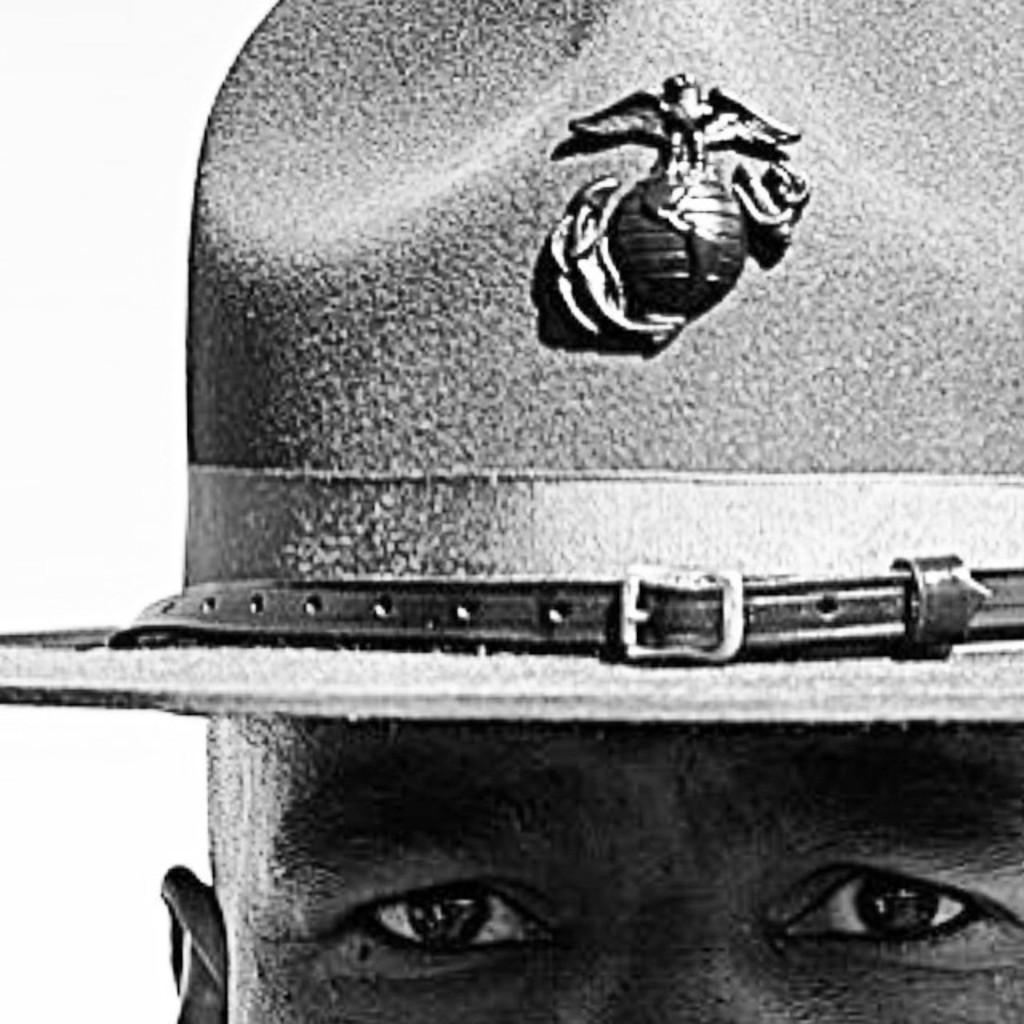Who or what is the main subject of the image? There is a person in the image. What can be seen on the person's face? The person's face is visible in the image. What type of clothing is the person wearing on their head? The person is wearing a cap in the image. What color scheme is used in the image? The image is in black and white. What type of pin can be seen on the person's shirt in the image? There is no pin visible on the person's shirt in the image. What nation does the person represent in the image? The image does not provide any information about the person's nationality or the nation they represent. 